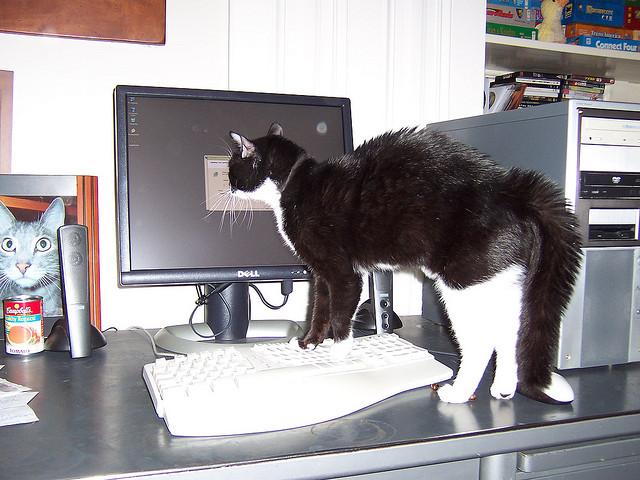Identify the text contained in this image. DELL 